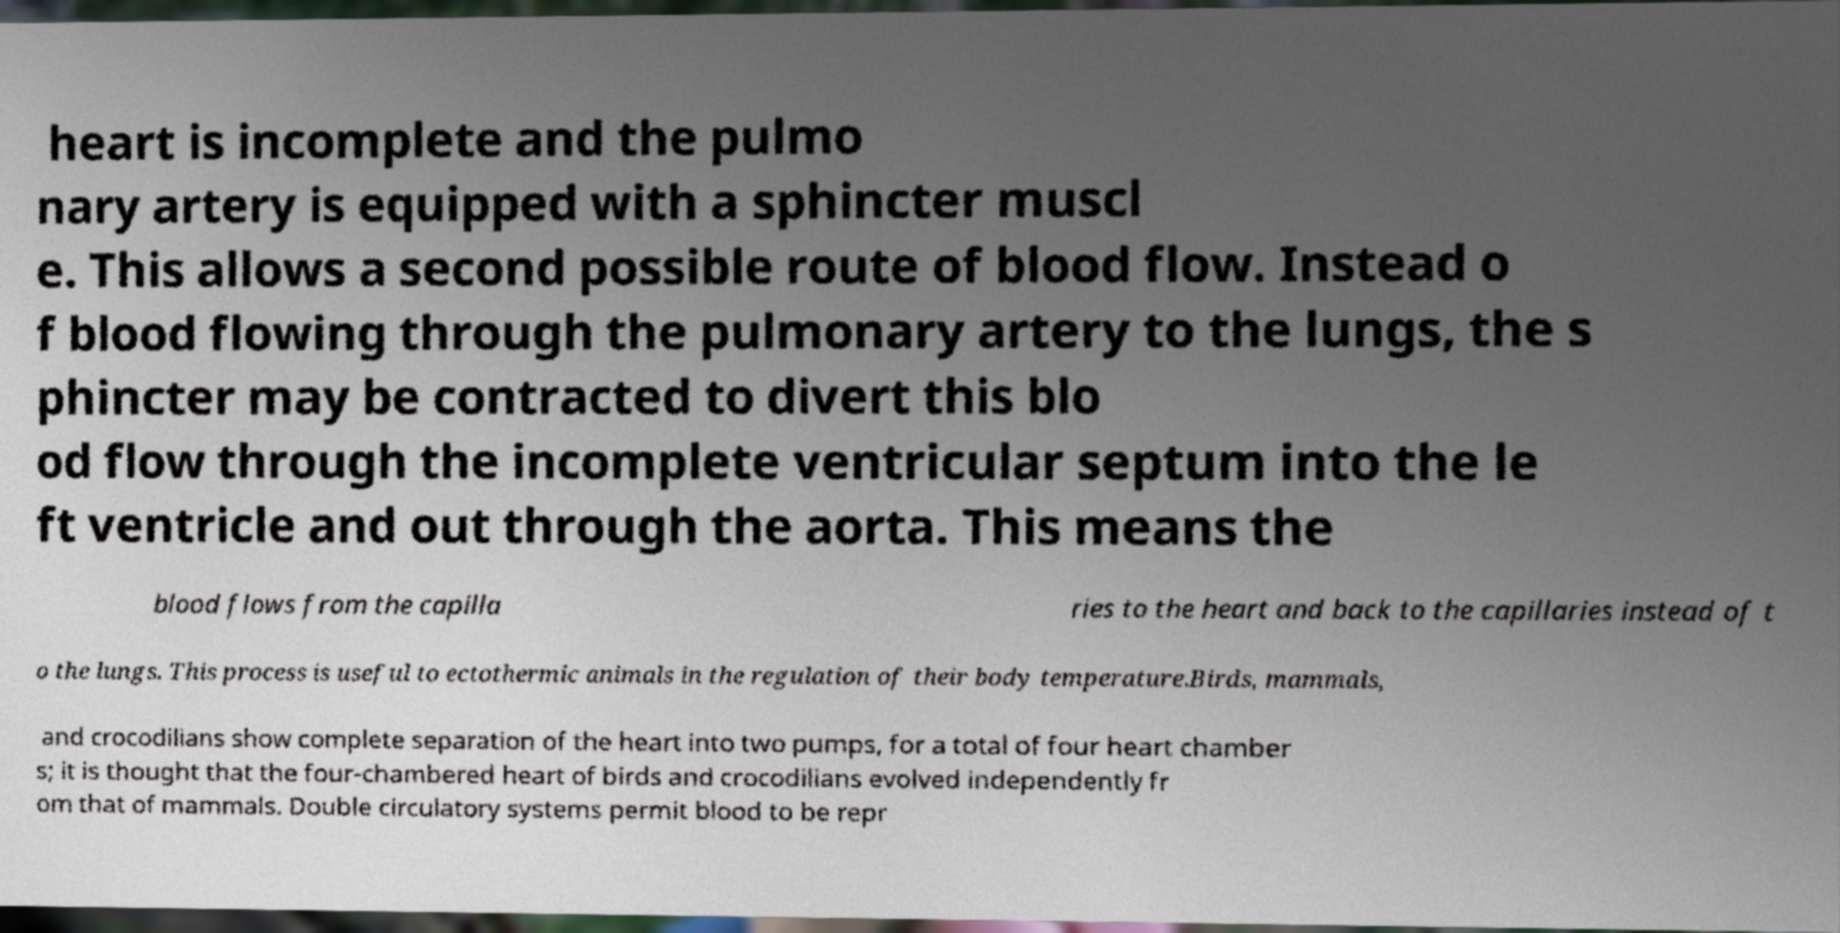For documentation purposes, I need the text within this image transcribed. Could you provide that? heart is incomplete and the pulmo nary artery is equipped with a sphincter muscl e. This allows a second possible route of blood flow. Instead o f blood flowing through the pulmonary artery to the lungs, the s phincter may be contracted to divert this blo od flow through the incomplete ventricular septum into the le ft ventricle and out through the aorta. This means the blood flows from the capilla ries to the heart and back to the capillaries instead of t o the lungs. This process is useful to ectothermic animals in the regulation of their body temperature.Birds, mammals, and crocodilians show complete separation of the heart into two pumps, for a total of four heart chamber s; it is thought that the four-chambered heart of birds and crocodilians evolved independently fr om that of mammals. Double circulatory systems permit blood to be repr 